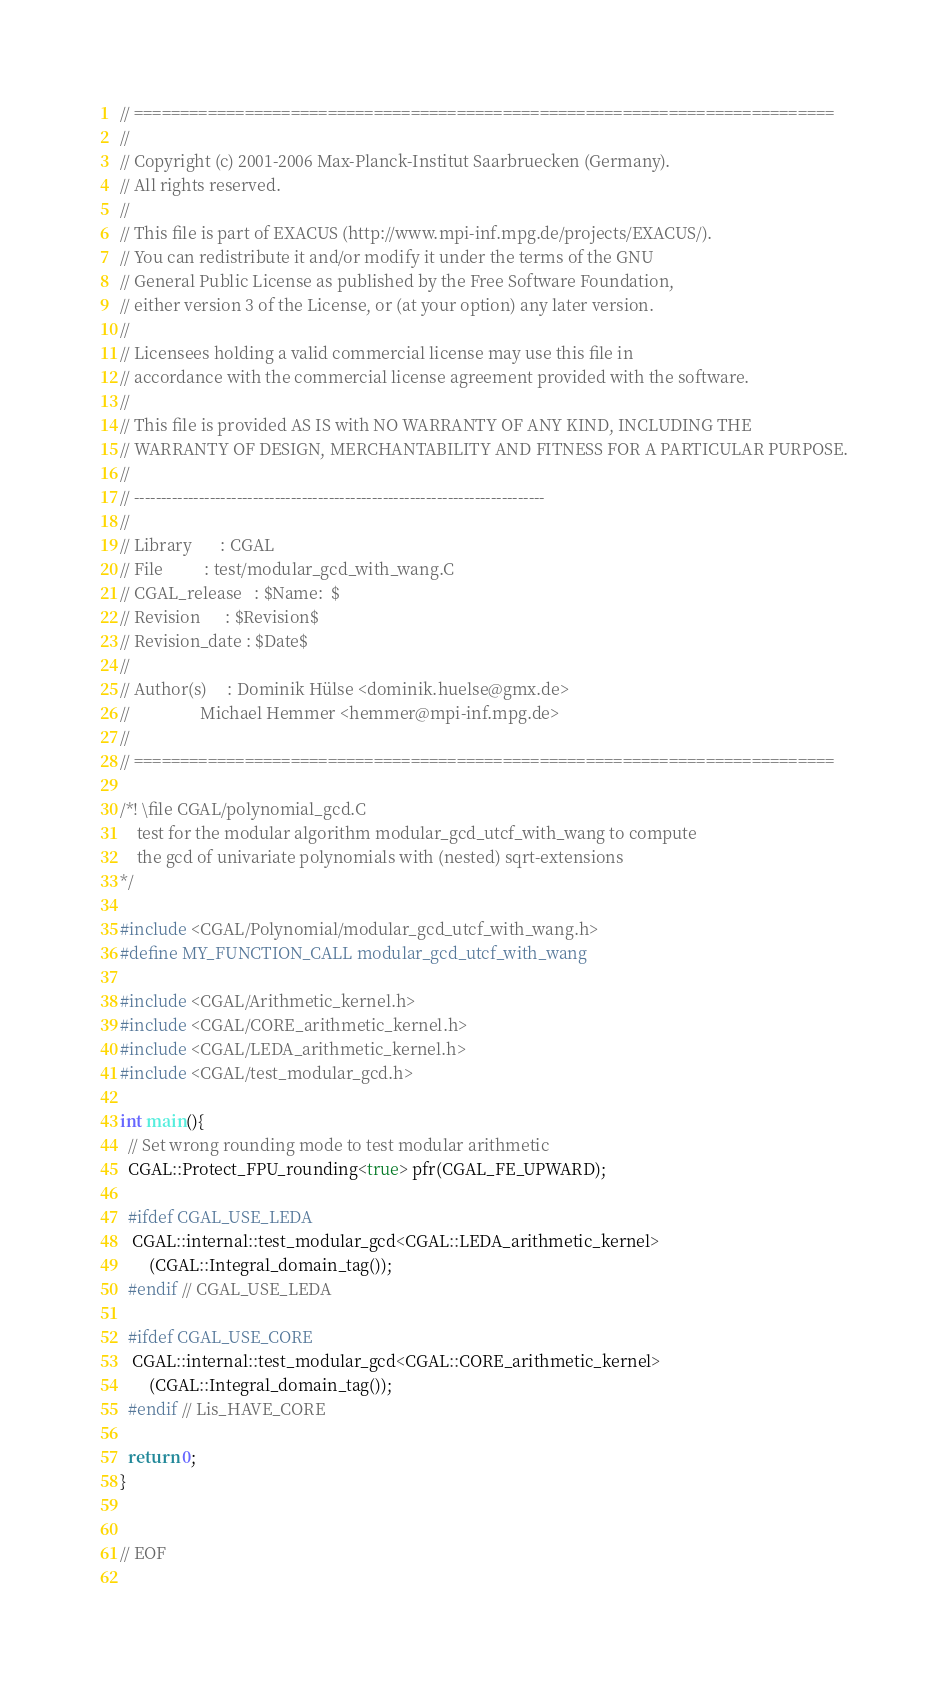<code> <loc_0><loc_0><loc_500><loc_500><_C++_>// ============================================================================
// 
// Copyright (c) 2001-2006 Max-Planck-Institut Saarbruecken (Germany).
// All rights reserved.
// 
// This file is part of EXACUS (http://www.mpi-inf.mpg.de/projects/EXACUS/).
// You can redistribute it and/or modify it under the terms of the GNU
// General Public License as published by the Free Software Foundation,
// either version 3 of the License, or (at your option) any later version.
//
// Licensees holding a valid commercial license may use this file in
// accordance with the commercial license agreement provided with the software.
//
// This file is provided AS IS with NO WARRANTY OF ANY KIND, INCLUDING THE
// WARRANTY OF DESIGN, MERCHANTABILITY AND FITNESS FOR A PARTICULAR PURPOSE.
//
// ----------------------------------------------------------------------------
//
// Library       : CGAL
// File          : test/modular_gcd_with_wang.C
// CGAL_release   : $Name:  $
// Revision      : $Revision$
// Revision_date : $Date$
//
// Author(s)     : Dominik Hülse <dominik.huelse@gmx.de>
//                 Michael Hemmer <hemmer@mpi-inf.mpg.de>
//
// ============================================================================

/*! \file CGAL/polynomial_gcd.C 
    test for the modular algorithm modular_gcd_utcf_with_wang to compute 
    the gcd of univariate polynomials with (nested) sqrt-extensions
*/

#include <CGAL/Polynomial/modular_gcd_utcf_with_wang.h>
#define MY_FUNCTION_CALL modular_gcd_utcf_with_wang

#include <CGAL/Arithmetic_kernel.h>
#include <CGAL/CORE_arithmetic_kernel.h>
#include <CGAL/LEDA_arithmetic_kernel.h>
#include <CGAL/test_modular_gcd.h>

int main(){
  // Set wrong rounding mode to test modular arithmetic 
  CGAL::Protect_FPU_rounding<true> pfr(CGAL_FE_UPWARD);

  #ifdef CGAL_USE_LEDA
   CGAL::internal::test_modular_gcd<CGAL::LEDA_arithmetic_kernel>
       (CGAL::Integral_domain_tag()); 
  #endif // CGAL_USE_LEDA    

  #ifdef CGAL_USE_CORE      
   CGAL::internal::test_modular_gcd<CGAL::CORE_arithmetic_kernel>
       (CGAL::Integral_domain_tag());
  #endif // Lis_HAVE_CORE
     
  return 0;
}


// EOF
 
</code> 